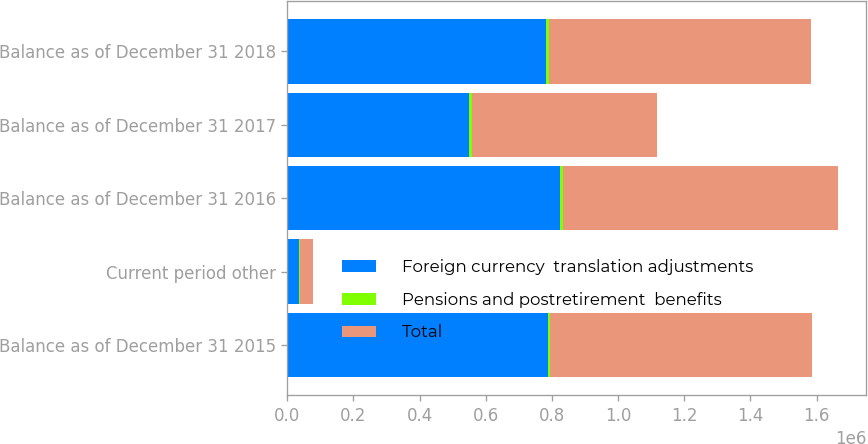<chart> <loc_0><loc_0><loc_500><loc_500><stacked_bar_chart><ecel><fcel>Balance as of December 31 2015<fcel>Current period other<fcel>Balance as of December 31 2016<fcel>Balance as of December 31 2017<fcel>Balance as of December 31 2018<nl><fcel>Foreign currency  translation adjustments<fcel>788652<fcel>36702<fcel>825354<fcel>547927<fcel>782102<nl><fcel>Pensions and postretirement  benefits<fcel>4916<fcel>2757<fcel>7673<fcel>10600<fcel>9506<nl><fcel>Total<fcel>793568<fcel>39459<fcel>833027<fcel>558527<fcel>791608<nl></chart> 